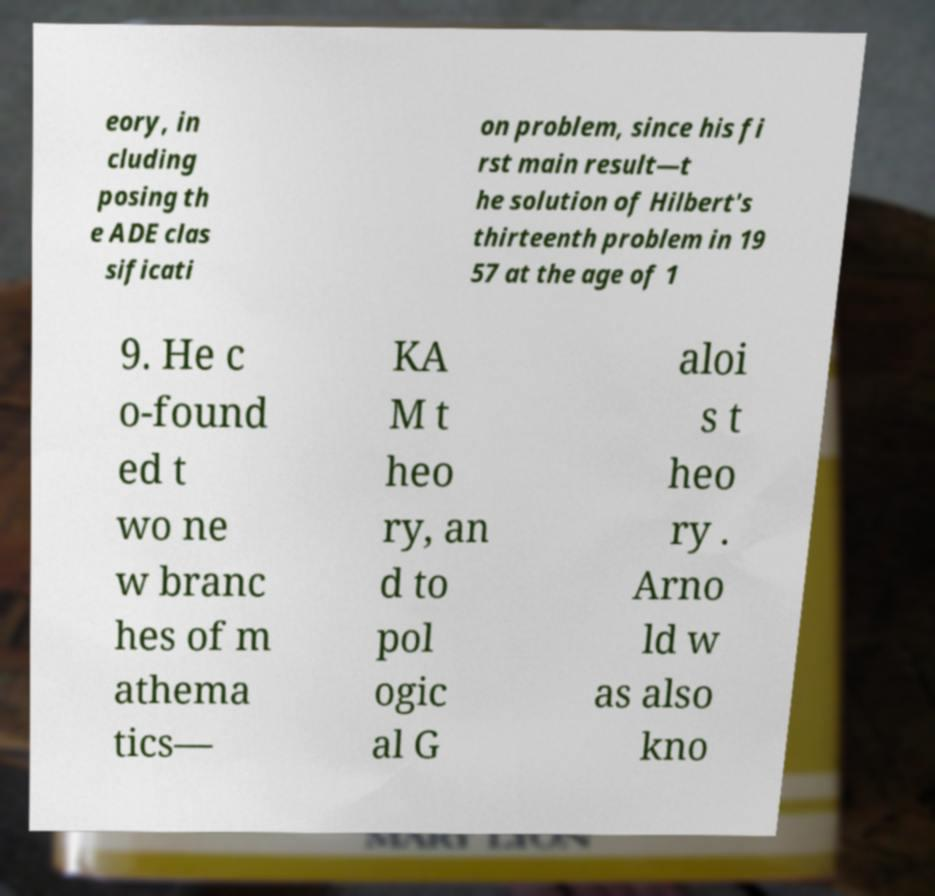Could you extract and type out the text from this image? eory, in cluding posing th e ADE clas sificati on problem, since his fi rst main result—t he solution of Hilbert's thirteenth problem in 19 57 at the age of 1 9. He c o-found ed t wo ne w branc hes of m athema tics— KA M t heo ry, an d to pol ogic al G aloi s t heo ry . Arno ld w as also kno 